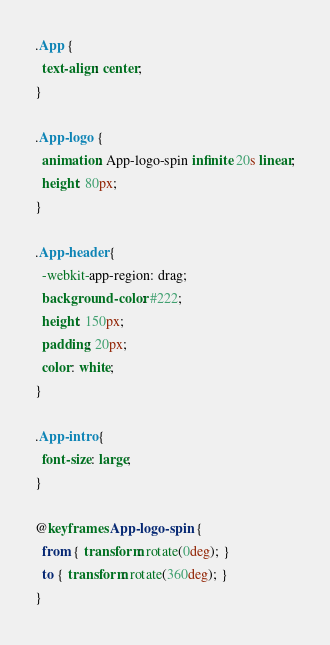<code> <loc_0><loc_0><loc_500><loc_500><_CSS_>.App {
  text-align: center;
}

.App-logo {
  animation: App-logo-spin infinite 20s linear;
  height: 80px;
}

.App-header {
  -webkit-app-region: drag;
  background-color: #222;
  height: 150px;
  padding: 20px;
  color: white;
}

.App-intro {
  font-size: large;
}

@keyframes App-logo-spin {
  from { transform: rotate(0deg); }
  to { transform: rotate(360deg); }
}
</code> 